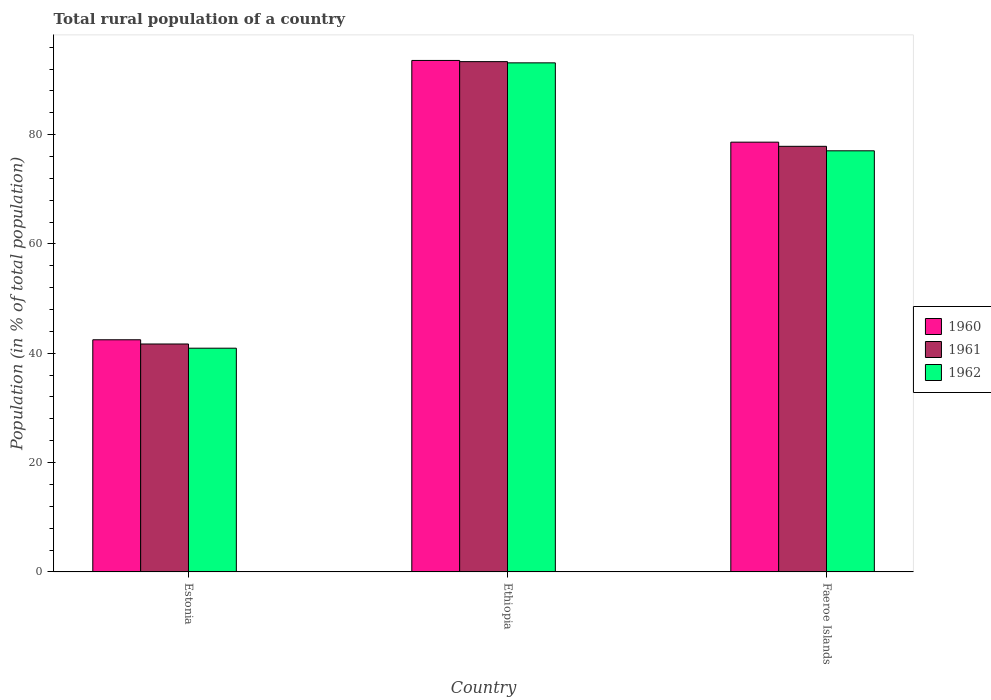How many different coloured bars are there?
Your response must be concise. 3. How many groups of bars are there?
Offer a terse response. 3. Are the number of bars per tick equal to the number of legend labels?
Your answer should be very brief. Yes. How many bars are there on the 1st tick from the left?
Keep it short and to the point. 3. How many bars are there on the 2nd tick from the right?
Provide a short and direct response. 3. What is the label of the 3rd group of bars from the left?
Your answer should be compact. Faeroe Islands. In how many cases, is the number of bars for a given country not equal to the number of legend labels?
Your response must be concise. 0. What is the rural population in 1960 in Estonia?
Ensure brevity in your answer.  42.47. Across all countries, what is the maximum rural population in 1960?
Your answer should be very brief. 93.57. Across all countries, what is the minimum rural population in 1962?
Keep it short and to the point. 40.93. In which country was the rural population in 1962 maximum?
Your answer should be compact. Ethiopia. In which country was the rural population in 1960 minimum?
Make the answer very short. Estonia. What is the total rural population in 1962 in the graph?
Your answer should be compact. 211.09. What is the difference between the rural population in 1962 in Ethiopia and that in Faeroe Islands?
Provide a short and direct response. 16.09. What is the difference between the rural population in 1961 in Faeroe Islands and the rural population in 1960 in Ethiopia?
Make the answer very short. -15.71. What is the average rural population in 1961 per country?
Offer a terse response. 70.97. What is the difference between the rural population of/in 1960 and rural population of/in 1962 in Estonia?
Your answer should be compact. 1.54. In how many countries, is the rural population in 1962 greater than 28 %?
Give a very brief answer. 3. What is the ratio of the rural population in 1962 in Estonia to that in Faeroe Islands?
Make the answer very short. 0.53. Is the rural population in 1960 in Estonia less than that in Ethiopia?
Keep it short and to the point. Yes. Is the difference between the rural population in 1960 in Ethiopia and Faeroe Islands greater than the difference between the rural population in 1962 in Ethiopia and Faeroe Islands?
Give a very brief answer. No. What is the difference between the highest and the second highest rural population in 1962?
Make the answer very short. -36.11. What is the difference between the highest and the lowest rural population in 1961?
Your answer should be compact. 51.65. Is the sum of the rural population in 1962 in Ethiopia and Faeroe Islands greater than the maximum rural population in 1961 across all countries?
Provide a short and direct response. Yes. Is it the case that in every country, the sum of the rural population in 1960 and rural population in 1961 is greater than the rural population in 1962?
Your response must be concise. Yes. How many countries are there in the graph?
Your answer should be compact. 3. Are the values on the major ticks of Y-axis written in scientific E-notation?
Give a very brief answer. No. Does the graph contain grids?
Keep it short and to the point. No. How many legend labels are there?
Ensure brevity in your answer.  3. How are the legend labels stacked?
Provide a succinct answer. Vertical. What is the title of the graph?
Ensure brevity in your answer.  Total rural population of a country. What is the label or title of the Y-axis?
Make the answer very short. Population (in % of total population). What is the Population (in % of total population) of 1960 in Estonia?
Provide a succinct answer. 42.47. What is the Population (in % of total population) in 1961 in Estonia?
Offer a terse response. 41.7. What is the Population (in % of total population) in 1962 in Estonia?
Your response must be concise. 40.93. What is the Population (in % of total population) in 1960 in Ethiopia?
Your response must be concise. 93.57. What is the Population (in % of total population) in 1961 in Ethiopia?
Offer a very short reply. 93.35. What is the Population (in % of total population) of 1962 in Ethiopia?
Make the answer very short. 93.13. What is the Population (in % of total population) in 1960 in Faeroe Islands?
Offer a very short reply. 78.62. What is the Population (in % of total population) in 1961 in Faeroe Islands?
Provide a short and direct response. 77.86. What is the Population (in % of total population) in 1962 in Faeroe Islands?
Offer a terse response. 77.04. Across all countries, what is the maximum Population (in % of total population) of 1960?
Make the answer very short. 93.57. Across all countries, what is the maximum Population (in % of total population) in 1961?
Your answer should be compact. 93.35. Across all countries, what is the maximum Population (in % of total population) in 1962?
Your response must be concise. 93.13. Across all countries, what is the minimum Population (in % of total population) in 1960?
Your response must be concise. 42.47. Across all countries, what is the minimum Population (in % of total population) in 1961?
Offer a terse response. 41.7. Across all countries, what is the minimum Population (in % of total population) of 1962?
Offer a terse response. 40.93. What is the total Population (in % of total population) in 1960 in the graph?
Ensure brevity in your answer.  214.65. What is the total Population (in % of total population) in 1961 in the graph?
Ensure brevity in your answer.  212.91. What is the total Population (in % of total population) of 1962 in the graph?
Provide a succinct answer. 211.09. What is the difference between the Population (in % of total population) of 1960 in Estonia and that in Ethiopia?
Provide a succinct answer. -51.1. What is the difference between the Population (in % of total population) of 1961 in Estonia and that in Ethiopia?
Offer a very short reply. -51.65. What is the difference between the Population (in % of total population) of 1962 in Estonia and that in Ethiopia?
Your answer should be compact. -52.2. What is the difference between the Population (in % of total population) in 1960 in Estonia and that in Faeroe Islands?
Give a very brief answer. -36.15. What is the difference between the Population (in % of total population) in 1961 in Estonia and that in Faeroe Islands?
Keep it short and to the point. -36.16. What is the difference between the Population (in % of total population) of 1962 in Estonia and that in Faeroe Islands?
Your answer should be compact. -36.11. What is the difference between the Population (in % of total population) of 1960 in Ethiopia and that in Faeroe Islands?
Your response must be concise. 14.95. What is the difference between the Population (in % of total population) of 1961 in Ethiopia and that in Faeroe Islands?
Your answer should be very brief. 15.49. What is the difference between the Population (in % of total population) of 1962 in Ethiopia and that in Faeroe Islands?
Keep it short and to the point. 16.09. What is the difference between the Population (in % of total population) of 1960 in Estonia and the Population (in % of total population) of 1961 in Ethiopia?
Provide a succinct answer. -50.88. What is the difference between the Population (in % of total population) of 1960 in Estonia and the Population (in % of total population) of 1962 in Ethiopia?
Provide a succinct answer. -50.66. What is the difference between the Population (in % of total population) in 1961 in Estonia and the Population (in % of total population) in 1962 in Ethiopia?
Ensure brevity in your answer.  -51.43. What is the difference between the Population (in % of total population) in 1960 in Estonia and the Population (in % of total population) in 1961 in Faeroe Islands?
Provide a short and direct response. -35.39. What is the difference between the Population (in % of total population) of 1960 in Estonia and the Population (in % of total population) of 1962 in Faeroe Islands?
Offer a terse response. -34.57. What is the difference between the Population (in % of total population) in 1961 in Estonia and the Population (in % of total population) in 1962 in Faeroe Islands?
Give a very brief answer. -35.34. What is the difference between the Population (in % of total population) of 1960 in Ethiopia and the Population (in % of total population) of 1961 in Faeroe Islands?
Give a very brief answer. 15.71. What is the difference between the Population (in % of total population) of 1960 in Ethiopia and the Population (in % of total population) of 1962 in Faeroe Islands?
Offer a terse response. 16.53. What is the difference between the Population (in % of total population) in 1961 in Ethiopia and the Population (in % of total population) in 1962 in Faeroe Islands?
Offer a very short reply. 16.31. What is the average Population (in % of total population) of 1960 per country?
Provide a short and direct response. 71.55. What is the average Population (in % of total population) of 1961 per country?
Your answer should be very brief. 70.97. What is the average Population (in % of total population) of 1962 per country?
Give a very brief answer. 70.36. What is the difference between the Population (in % of total population) of 1960 and Population (in % of total population) of 1961 in Estonia?
Offer a very short reply. 0.77. What is the difference between the Population (in % of total population) of 1960 and Population (in % of total population) of 1962 in Estonia?
Your answer should be compact. 1.54. What is the difference between the Population (in % of total population) of 1961 and Population (in % of total population) of 1962 in Estonia?
Make the answer very short. 0.77. What is the difference between the Population (in % of total population) of 1960 and Population (in % of total population) of 1961 in Ethiopia?
Your response must be concise. 0.22. What is the difference between the Population (in % of total population) in 1960 and Population (in % of total population) in 1962 in Ethiopia?
Your answer should be very brief. 0.44. What is the difference between the Population (in % of total population) in 1961 and Population (in % of total population) in 1962 in Ethiopia?
Make the answer very short. 0.22. What is the difference between the Population (in % of total population) in 1960 and Population (in % of total population) in 1961 in Faeroe Islands?
Offer a terse response. 0.76. What is the difference between the Population (in % of total population) in 1960 and Population (in % of total population) in 1962 in Faeroe Islands?
Ensure brevity in your answer.  1.58. What is the difference between the Population (in % of total population) in 1961 and Population (in % of total population) in 1962 in Faeroe Islands?
Your answer should be very brief. 0.82. What is the ratio of the Population (in % of total population) in 1960 in Estonia to that in Ethiopia?
Offer a very short reply. 0.45. What is the ratio of the Population (in % of total population) in 1961 in Estonia to that in Ethiopia?
Keep it short and to the point. 0.45. What is the ratio of the Population (in % of total population) of 1962 in Estonia to that in Ethiopia?
Give a very brief answer. 0.44. What is the ratio of the Population (in % of total population) in 1960 in Estonia to that in Faeroe Islands?
Keep it short and to the point. 0.54. What is the ratio of the Population (in % of total population) of 1961 in Estonia to that in Faeroe Islands?
Give a very brief answer. 0.54. What is the ratio of the Population (in % of total population) in 1962 in Estonia to that in Faeroe Islands?
Ensure brevity in your answer.  0.53. What is the ratio of the Population (in % of total population) of 1960 in Ethiopia to that in Faeroe Islands?
Your answer should be very brief. 1.19. What is the ratio of the Population (in % of total population) of 1961 in Ethiopia to that in Faeroe Islands?
Keep it short and to the point. 1.2. What is the ratio of the Population (in % of total population) in 1962 in Ethiopia to that in Faeroe Islands?
Offer a terse response. 1.21. What is the difference between the highest and the second highest Population (in % of total population) of 1960?
Provide a short and direct response. 14.95. What is the difference between the highest and the second highest Population (in % of total population) in 1961?
Make the answer very short. 15.49. What is the difference between the highest and the second highest Population (in % of total population) in 1962?
Offer a terse response. 16.09. What is the difference between the highest and the lowest Population (in % of total population) of 1960?
Offer a very short reply. 51.1. What is the difference between the highest and the lowest Population (in % of total population) of 1961?
Provide a short and direct response. 51.65. What is the difference between the highest and the lowest Population (in % of total population) in 1962?
Offer a terse response. 52.2. 